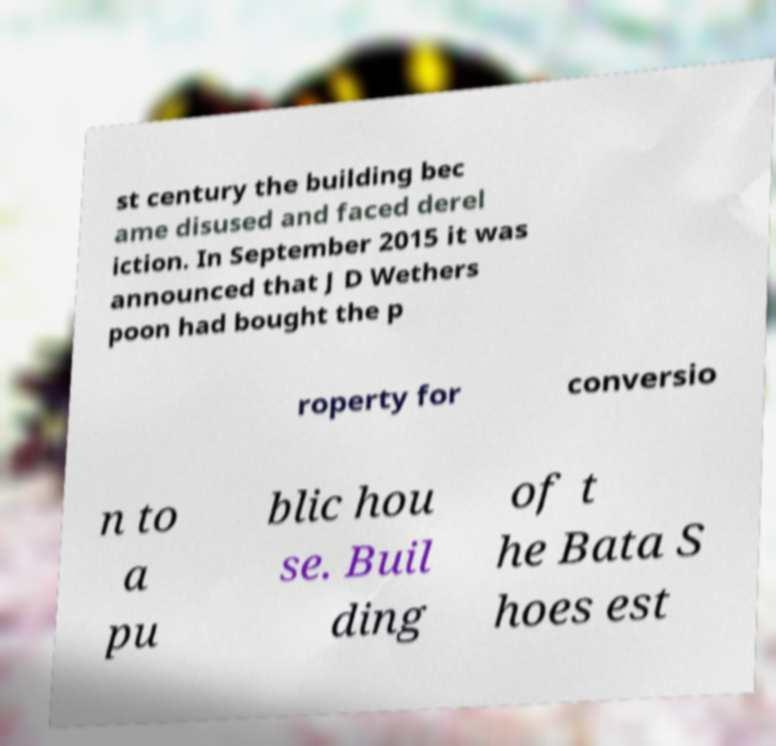Can you read and provide the text displayed in the image?This photo seems to have some interesting text. Can you extract and type it out for me? st century the building bec ame disused and faced derel iction. In September 2015 it was announced that J D Wethers poon had bought the p roperty for conversio n to a pu blic hou se. Buil ding of t he Bata S hoes est 